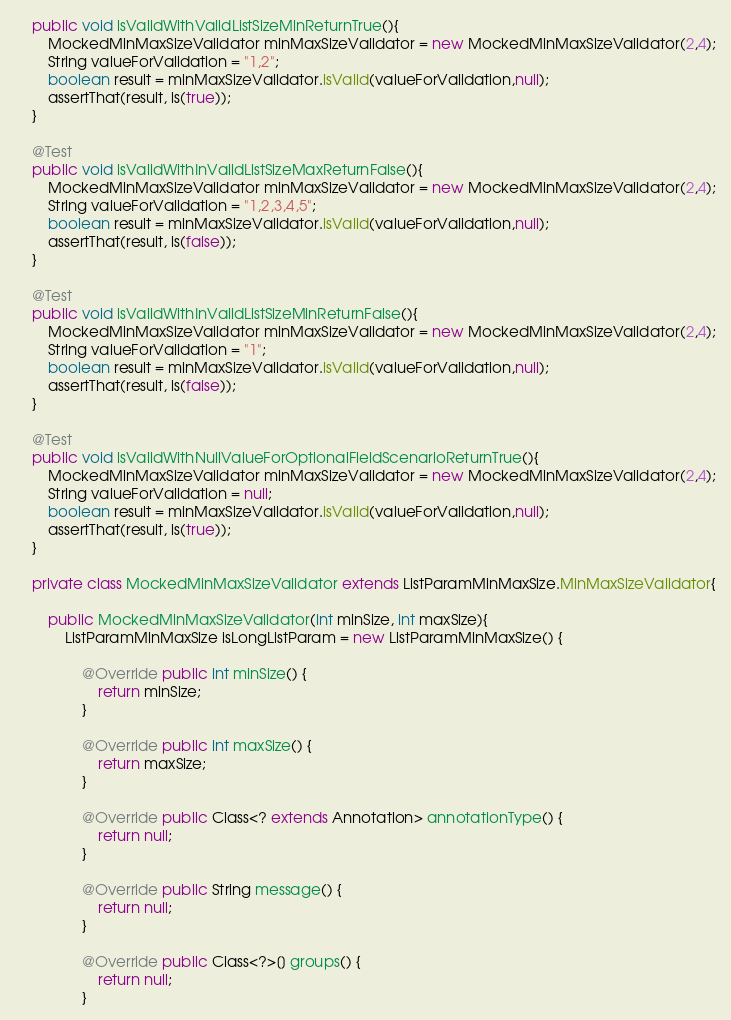<code> <loc_0><loc_0><loc_500><loc_500><_Java_>    public void isValidWithValidListSizeMinReturnTrue(){
        MockedMinMaxSizeValidator minMaxSizeValidator = new MockedMinMaxSizeValidator(2,4);
        String valueForValidation = "1,2";
        boolean result = minMaxSizeValidator.isValid(valueForValidation,null);
        assertThat(result, is(true));
    }

    @Test
    public void isValidWithInValidListSizeMaxReturnFalse(){
        MockedMinMaxSizeValidator minMaxSizeValidator = new MockedMinMaxSizeValidator(2,4);
        String valueForValidation = "1,2,3,4,5";
        boolean result = minMaxSizeValidator.isValid(valueForValidation,null);
        assertThat(result, is(false));
    }

    @Test
    public void isValidWithInValidListSizeMinReturnFalse(){
        MockedMinMaxSizeValidator minMaxSizeValidator = new MockedMinMaxSizeValidator(2,4);
        String valueForValidation = "1";
        boolean result = minMaxSizeValidator.isValid(valueForValidation,null);
        assertThat(result, is(false));
    }

    @Test
    public void isValidWithNullValueForOptionalFieldScenarioReturnTrue(){
        MockedMinMaxSizeValidator minMaxSizeValidator = new MockedMinMaxSizeValidator(2,4);
        String valueForValidation = null;
        boolean result = minMaxSizeValidator.isValid(valueForValidation,null);
        assertThat(result, is(true));
    }

    private class MockedMinMaxSizeValidator extends ListParamMinMaxSize.MinMaxSizeValidator{

        public MockedMinMaxSizeValidator(int minSize, int maxSize){
            ListParamMinMaxSize isLongListParam = new ListParamMinMaxSize() {

                @Override public int minSize() {
                    return minSize;
                }

                @Override public int maxSize() {
                    return maxSize;
                }

                @Override public Class<? extends Annotation> annotationType() {
                    return null;
                }

                @Override public String message() {
                    return null;
                }

                @Override public Class<?>[] groups() {
                    return null;
                }
</code> 